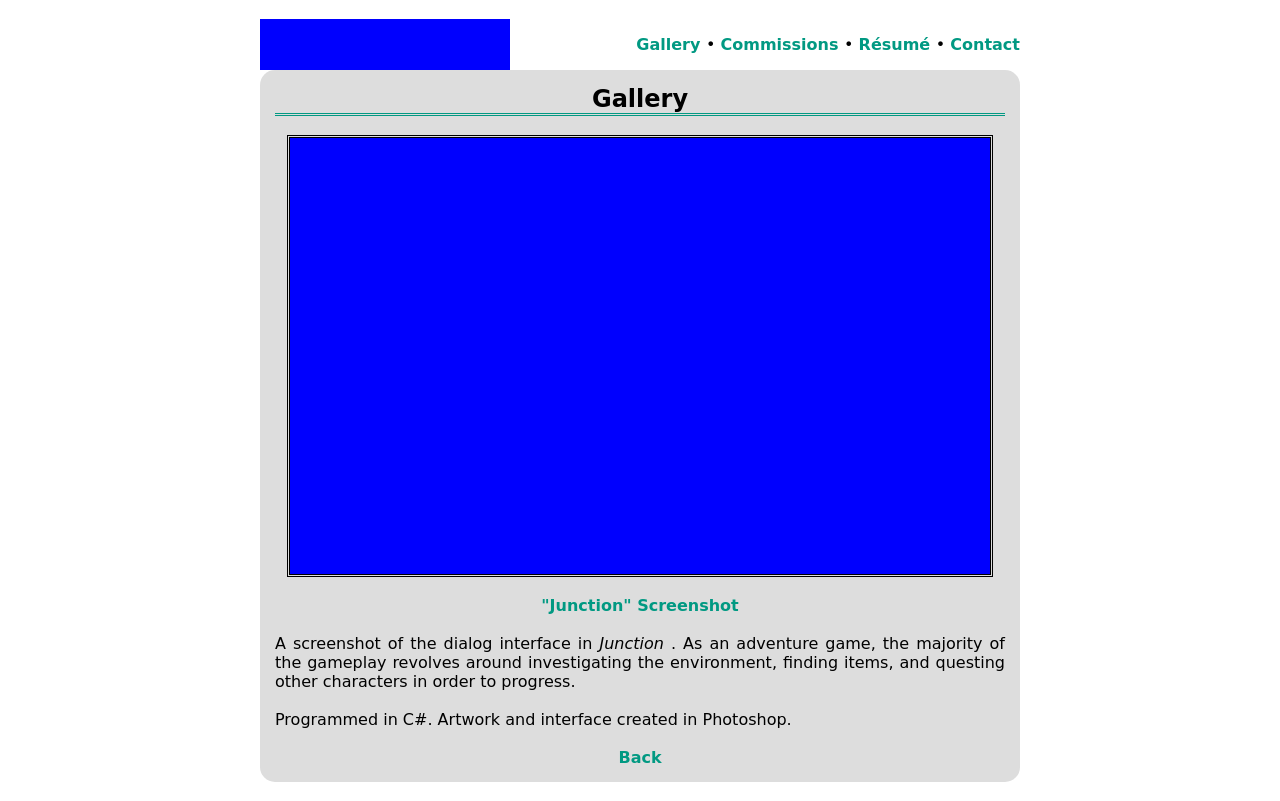Can you tell me more about the game mechanics in 'Junction' based on this screenshot? Based on the screenshot of 'Junction', the game likely involves a point-and-click interface where players interact with objects and characters within the environment to solve puzzles and advance the plot. The dialog box implies a choice-based mechanic where player responses influence the outcome of events, hinting at a branching story structure. 